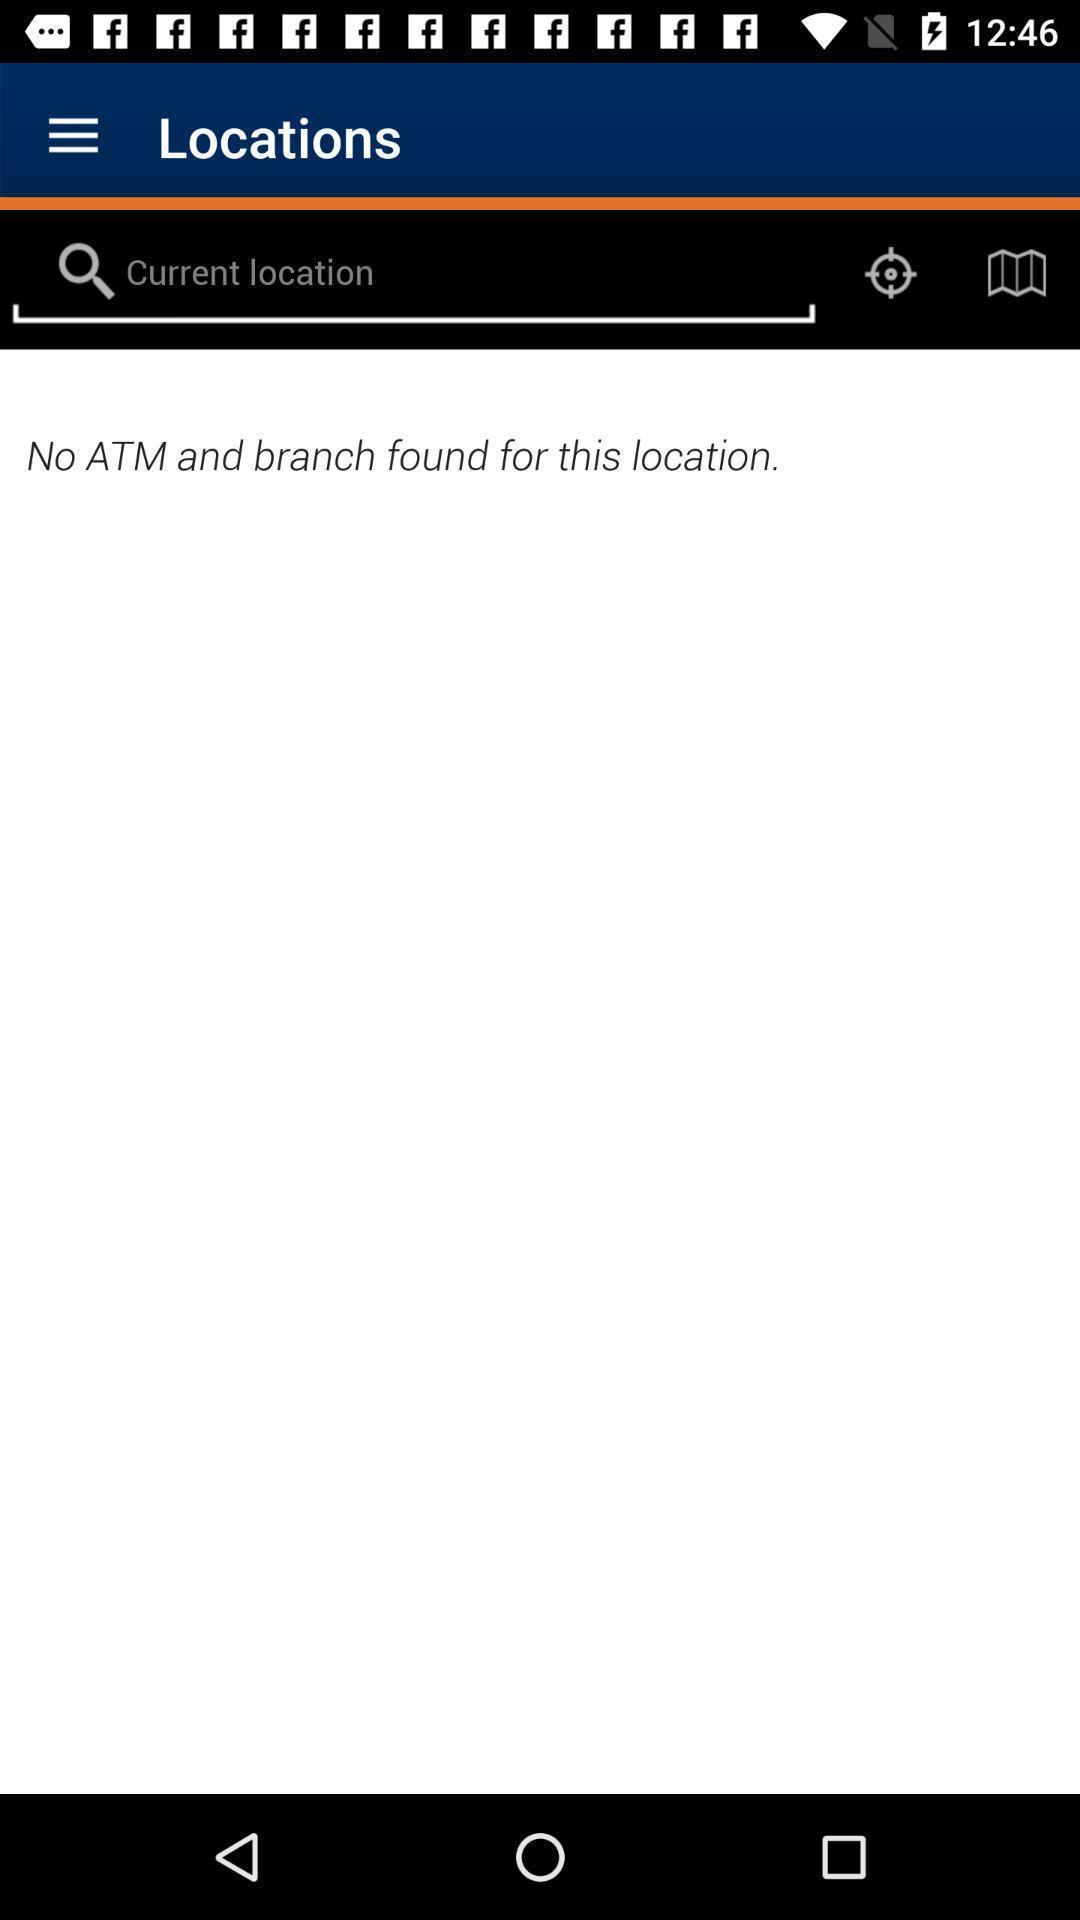What can you discern from this picture? Screen showing locations page with search bar. 